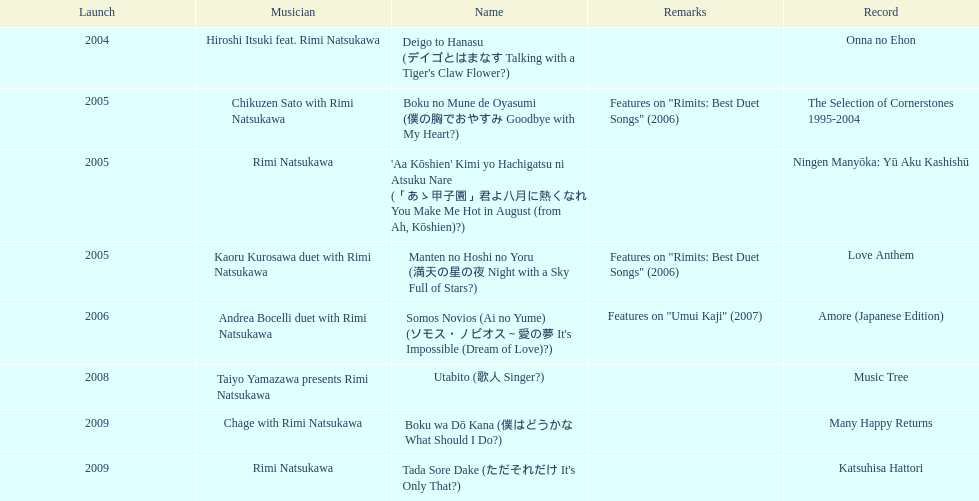Which was not released in 2004, onna no ehon or music tree? Music Tree. 